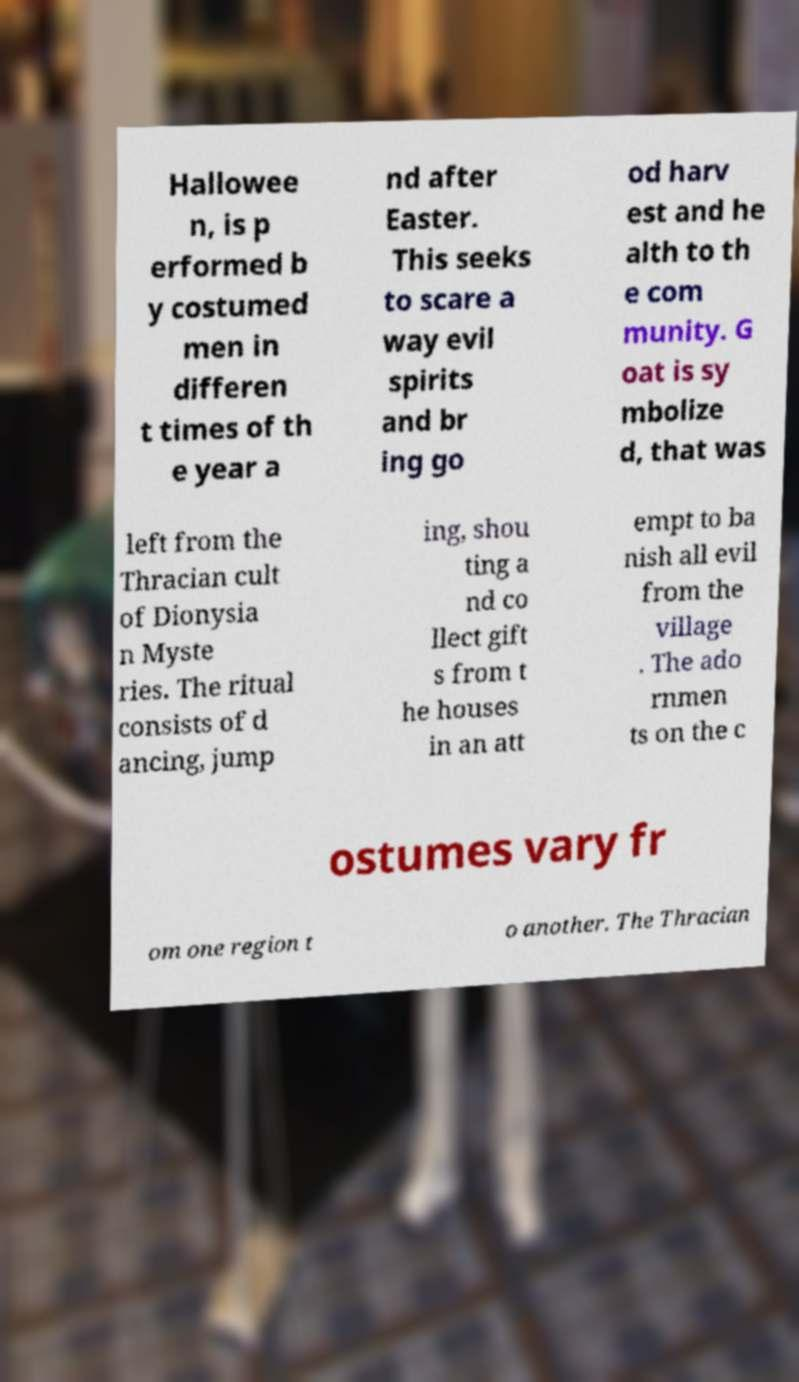What messages or text are displayed in this image? I need them in a readable, typed format. Hallowee n, is p erformed b y costumed men in differen t times of th e year a nd after Easter. This seeks to scare a way evil spirits and br ing go od harv est and he alth to th e com munity. G oat is sy mbolize d, that was left from the Thracian cult of Dionysia n Myste ries. The ritual consists of d ancing, jump ing, shou ting a nd co llect gift s from t he houses in an att empt to ba nish all evil from the village . The ado rnmen ts on the c ostumes vary fr om one region t o another. The Thracian 